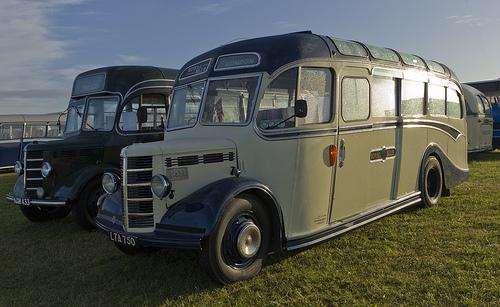Question: what vehicle is shown?
Choices:
A. A train.
B. Vintage buses.
C. A car.
D. A plane.
Answer with the letter. Answer: B Question: what color is the grass?
Choices:
A. Brown.
B. Yellow.
C. Green.
D. Black.
Answer with the letter. Answer: C Question: where is this shot?
Choices:
A. Beach.
B. Street.
C. Lake.
D. Field.
Answer with the letter. Answer: D Question: when was this taken?
Choices:
A. Morning.
B. Evening.
C. Daytime.
D. Nighttime.
Answer with the letter. Answer: C Question: how many people are there?
Choices:
A. 0.
B. 1.
C. 2.
D. 3.
Answer with the letter. Answer: A 